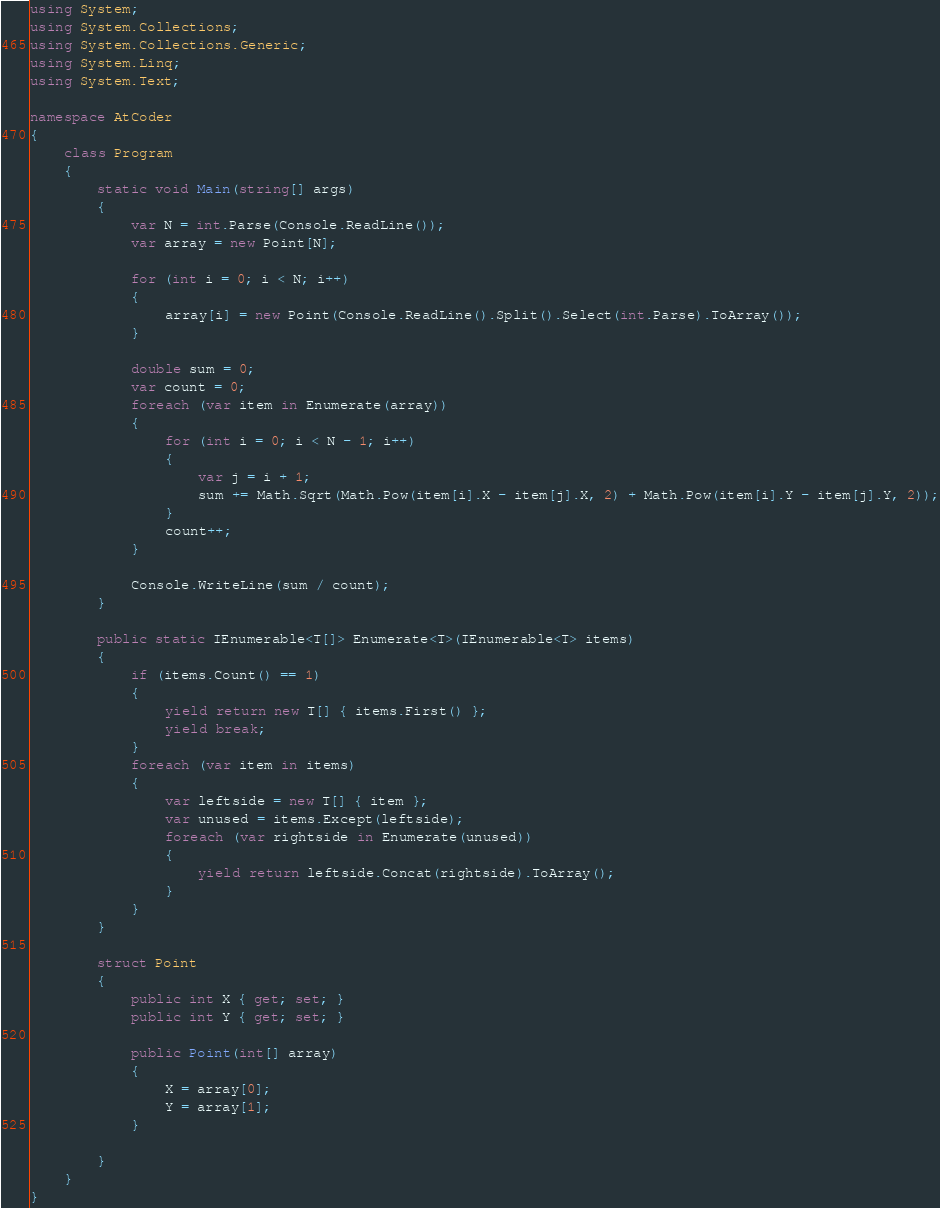<code> <loc_0><loc_0><loc_500><loc_500><_C#_>using System;
using System.Collections;
using System.Collections.Generic;
using System.Linq;
using System.Text;

namespace AtCoder
{
    class Program
    {
        static void Main(string[] args)
        {
            var N = int.Parse(Console.ReadLine());
            var array = new Point[N];

            for (int i = 0; i < N; i++)
            {
                array[i] = new Point(Console.ReadLine().Split().Select(int.Parse).ToArray());
            }

            double sum = 0;
            var count = 0;
            foreach (var item in Enumerate(array))
            {
                for (int i = 0; i < N - 1; i++)
                {
                    var j = i + 1;
                    sum += Math.Sqrt(Math.Pow(item[i].X - item[j].X, 2) + Math.Pow(item[i].Y - item[j].Y, 2));
                }
                count++;
            }

            Console.WriteLine(sum / count);
        }

        public static IEnumerable<T[]> Enumerate<T>(IEnumerable<T> items)
        {
            if (items.Count() == 1)
            {
                yield return new T[] { items.First() };
                yield break;
            }
            foreach (var item in items)
            {
                var leftside = new T[] { item };
                var unused = items.Except(leftside);
                foreach (var rightside in Enumerate(unused))
                {
                    yield return leftside.Concat(rightside).ToArray();
                }
            }
        }

        struct Point
        {
            public int X { get; set; }
            public int Y { get; set; }

            public Point(int[] array)
            {
                X = array[0];
                Y = array[1];
            }

        }
    }
}
</code> 